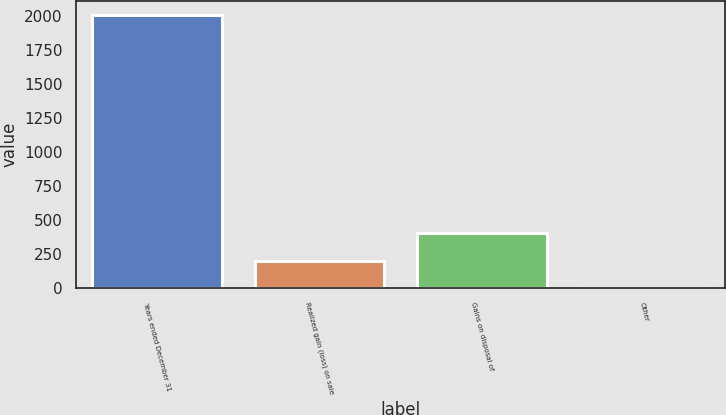Convert chart. <chart><loc_0><loc_0><loc_500><loc_500><bar_chart><fcel>Years ended December 31<fcel>Realized gain (loss) on sale<fcel>Gains on disposal of<fcel>Other<nl><fcel>2007<fcel>201.6<fcel>402.2<fcel>1<nl></chart> 